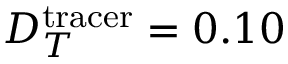<formula> <loc_0><loc_0><loc_500><loc_500>D _ { T } ^ { t r a c e r } = 0 . 1 0</formula> 